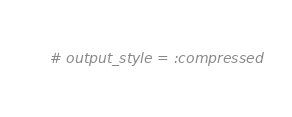<code> <loc_0><loc_0><loc_500><loc_500><_Ruby_># output_style = :compressed
</code> 